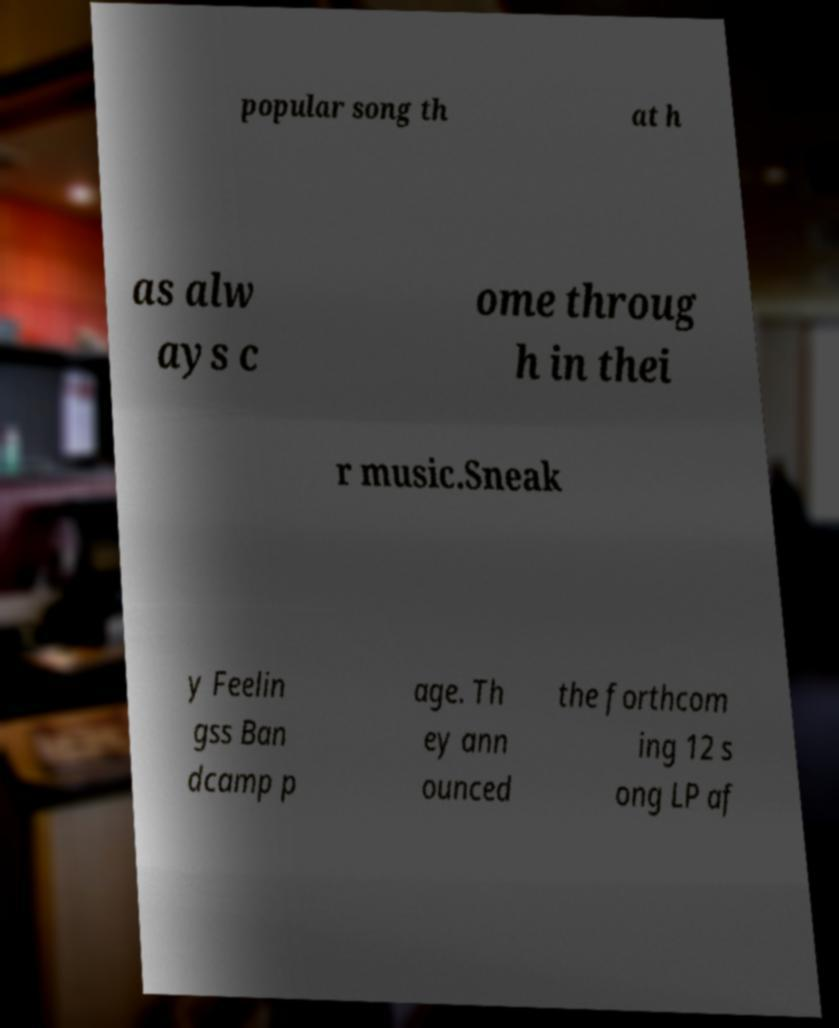Could you extract and type out the text from this image? popular song th at h as alw ays c ome throug h in thei r music.Sneak y Feelin gss Ban dcamp p age. Th ey ann ounced the forthcom ing 12 s ong LP af 